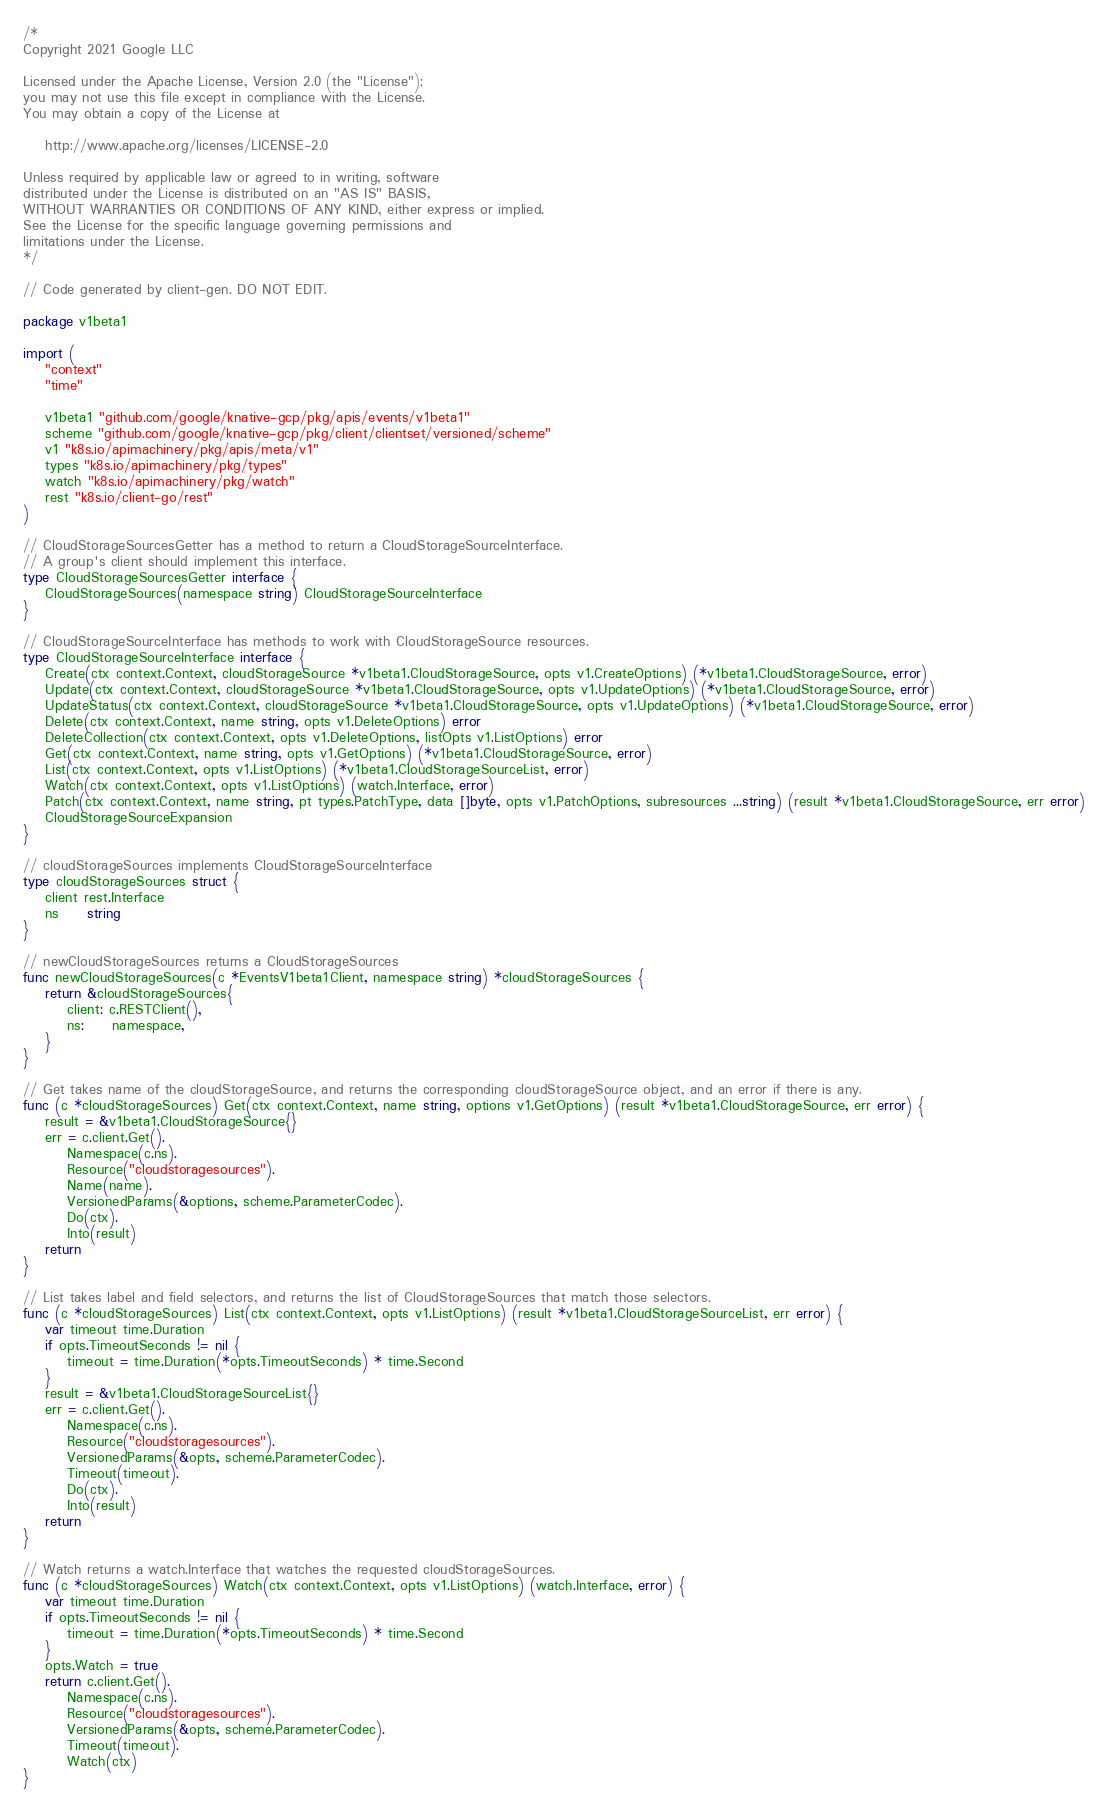<code> <loc_0><loc_0><loc_500><loc_500><_Go_>/*
Copyright 2021 Google LLC

Licensed under the Apache License, Version 2.0 (the "License");
you may not use this file except in compliance with the License.
You may obtain a copy of the License at

    http://www.apache.org/licenses/LICENSE-2.0

Unless required by applicable law or agreed to in writing, software
distributed under the License is distributed on an "AS IS" BASIS,
WITHOUT WARRANTIES OR CONDITIONS OF ANY KIND, either express or implied.
See the License for the specific language governing permissions and
limitations under the License.
*/

// Code generated by client-gen. DO NOT EDIT.

package v1beta1

import (
	"context"
	"time"

	v1beta1 "github.com/google/knative-gcp/pkg/apis/events/v1beta1"
	scheme "github.com/google/knative-gcp/pkg/client/clientset/versioned/scheme"
	v1 "k8s.io/apimachinery/pkg/apis/meta/v1"
	types "k8s.io/apimachinery/pkg/types"
	watch "k8s.io/apimachinery/pkg/watch"
	rest "k8s.io/client-go/rest"
)

// CloudStorageSourcesGetter has a method to return a CloudStorageSourceInterface.
// A group's client should implement this interface.
type CloudStorageSourcesGetter interface {
	CloudStorageSources(namespace string) CloudStorageSourceInterface
}

// CloudStorageSourceInterface has methods to work with CloudStorageSource resources.
type CloudStorageSourceInterface interface {
	Create(ctx context.Context, cloudStorageSource *v1beta1.CloudStorageSource, opts v1.CreateOptions) (*v1beta1.CloudStorageSource, error)
	Update(ctx context.Context, cloudStorageSource *v1beta1.CloudStorageSource, opts v1.UpdateOptions) (*v1beta1.CloudStorageSource, error)
	UpdateStatus(ctx context.Context, cloudStorageSource *v1beta1.CloudStorageSource, opts v1.UpdateOptions) (*v1beta1.CloudStorageSource, error)
	Delete(ctx context.Context, name string, opts v1.DeleteOptions) error
	DeleteCollection(ctx context.Context, opts v1.DeleteOptions, listOpts v1.ListOptions) error
	Get(ctx context.Context, name string, opts v1.GetOptions) (*v1beta1.CloudStorageSource, error)
	List(ctx context.Context, opts v1.ListOptions) (*v1beta1.CloudStorageSourceList, error)
	Watch(ctx context.Context, opts v1.ListOptions) (watch.Interface, error)
	Patch(ctx context.Context, name string, pt types.PatchType, data []byte, opts v1.PatchOptions, subresources ...string) (result *v1beta1.CloudStorageSource, err error)
	CloudStorageSourceExpansion
}

// cloudStorageSources implements CloudStorageSourceInterface
type cloudStorageSources struct {
	client rest.Interface
	ns     string
}

// newCloudStorageSources returns a CloudStorageSources
func newCloudStorageSources(c *EventsV1beta1Client, namespace string) *cloudStorageSources {
	return &cloudStorageSources{
		client: c.RESTClient(),
		ns:     namespace,
	}
}

// Get takes name of the cloudStorageSource, and returns the corresponding cloudStorageSource object, and an error if there is any.
func (c *cloudStorageSources) Get(ctx context.Context, name string, options v1.GetOptions) (result *v1beta1.CloudStorageSource, err error) {
	result = &v1beta1.CloudStorageSource{}
	err = c.client.Get().
		Namespace(c.ns).
		Resource("cloudstoragesources").
		Name(name).
		VersionedParams(&options, scheme.ParameterCodec).
		Do(ctx).
		Into(result)
	return
}

// List takes label and field selectors, and returns the list of CloudStorageSources that match those selectors.
func (c *cloudStorageSources) List(ctx context.Context, opts v1.ListOptions) (result *v1beta1.CloudStorageSourceList, err error) {
	var timeout time.Duration
	if opts.TimeoutSeconds != nil {
		timeout = time.Duration(*opts.TimeoutSeconds) * time.Second
	}
	result = &v1beta1.CloudStorageSourceList{}
	err = c.client.Get().
		Namespace(c.ns).
		Resource("cloudstoragesources").
		VersionedParams(&opts, scheme.ParameterCodec).
		Timeout(timeout).
		Do(ctx).
		Into(result)
	return
}

// Watch returns a watch.Interface that watches the requested cloudStorageSources.
func (c *cloudStorageSources) Watch(ctx context.Context, opts v1.ListOptions) (watch.Interface, error) {
	var timeout time.Duration
	if opts.TimeoutSeconds != nil {
		timeout = time.Duration(*opts.TimeoutSeconds) * time.Second
	}
	opts.Watch = true
	return c.client.Get().
		Namespace(c.ns).
		Resource("cloudstoragesources").
		VersionedParams(&opts, scheme.ParameterCodec).
		Timeout(timeout).
		Watch(ctx)
}
</code> 